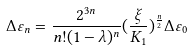<formula> <loc_0><loc_0><loc_500><loc_500>\Delta \varepsilon _ { n } = \frac { 2 ^ { 3 n } } { n ! ( 1 - \lambda ) ^ { n } } ( \frac { \xi } { K _ { 1 } } ) ^ { \frac { n } { 2 } } \Delta \varepsilon _ { 0 }</formula> 